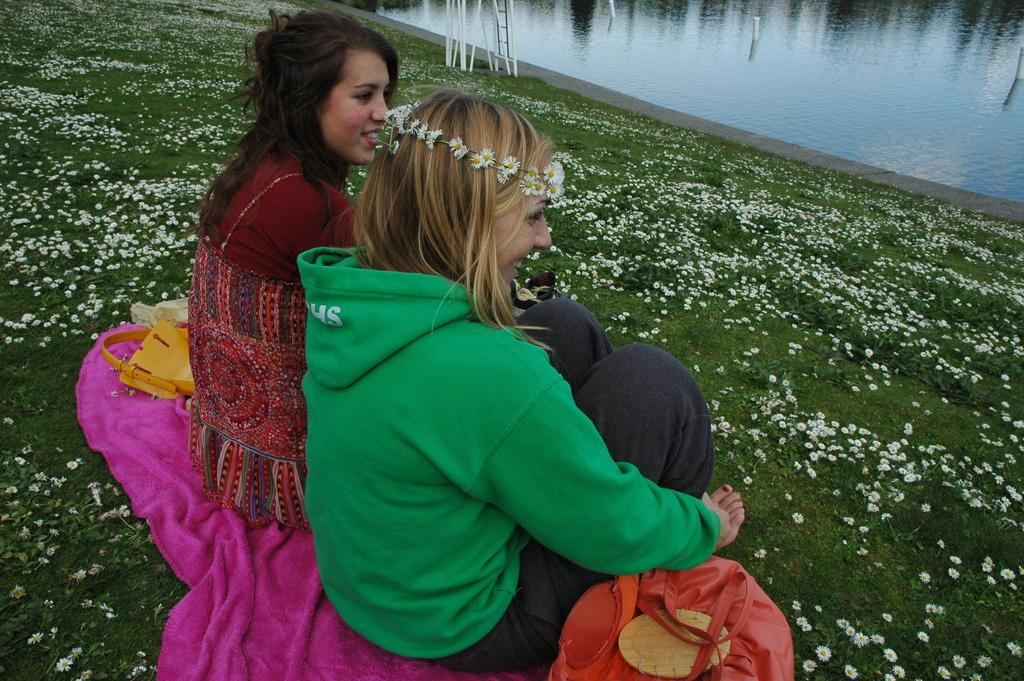How many women are in the foreground of the picture? There are two women in the foreground of the picture. What can be seen in the foreground besides the women? Cloth, handbags, grass, and flowers are visible in the foreground. What is the terrain like in the foreground? The terrain in the foreground includes grass and flowers. What is visible at the top of the image? There is a water body at the top of the image. What type of toys can be seen in the hands of the women in the image? There are no toys visible in the image; the women are not holding any toys. Is there a horse present in the image? No, there is no horse present in the image. 